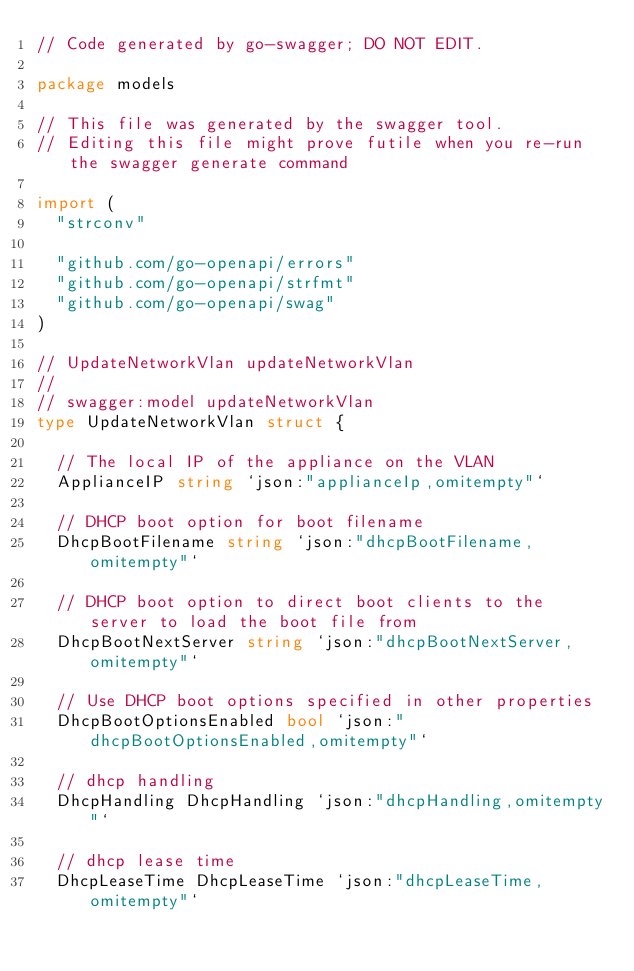<code> <loc_0><loc_0><loc_500><loc_500><_Go_>// Code generated by go-swagger; DO NOT EDIT.

package models

// This file was generated by the swagger tool.
// Editing this file might prove futile when you re-run the swagger generate command

import (
	"strconv"

	"github.com/go-openapi/errors"
	"github.com/go-openapi/strfmt"
	"github.com/go-openapi/swag"
)

// UpdateNetworkVlan updateNetworkVlan
//
// swagger:model updateNetworkVlan
type UpdateNetworkVlan struct {

	// The local IP of the appliance on the VLAN
	ApplianceIP string `json:"applianceIp,omitempty"`

	// DHCP boot option for boot filename
	DhcpBootFilename string `json:"dhcpBootFilename,omitempty"`

	// DHCP boot option to direct boot clients to the server to load the boot file from
	DhcpBootNextServer string `json:"dhcpBootNextServer,omitempty"`

	// Use DHCP boot options specified in other properties
	DhcpBootOptionsEnabled bool `json:"dhcpBootOptionsEnabled,omitempty"`

	// dhcp handling
	DhcpHandling DhcpHandling `json:"dhcpHandling,omitempty"`

	// dhcp lease time
	DhcpLeaseTime DhcpLeaseTime `json:"dhcpLeaseTime,omitempty"`
</code> 